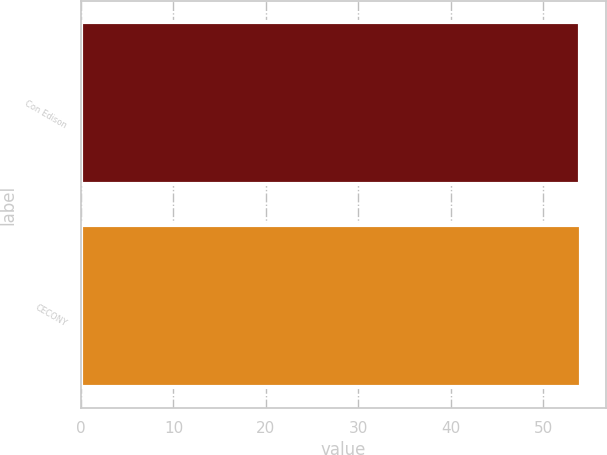<chart> <loc_0><loc_0><loc_500><loc_500><bar_chart><fcel>Con Edison<fcel>CECONY<nl><fcel>54<fcel>54.1<nl></chart> 